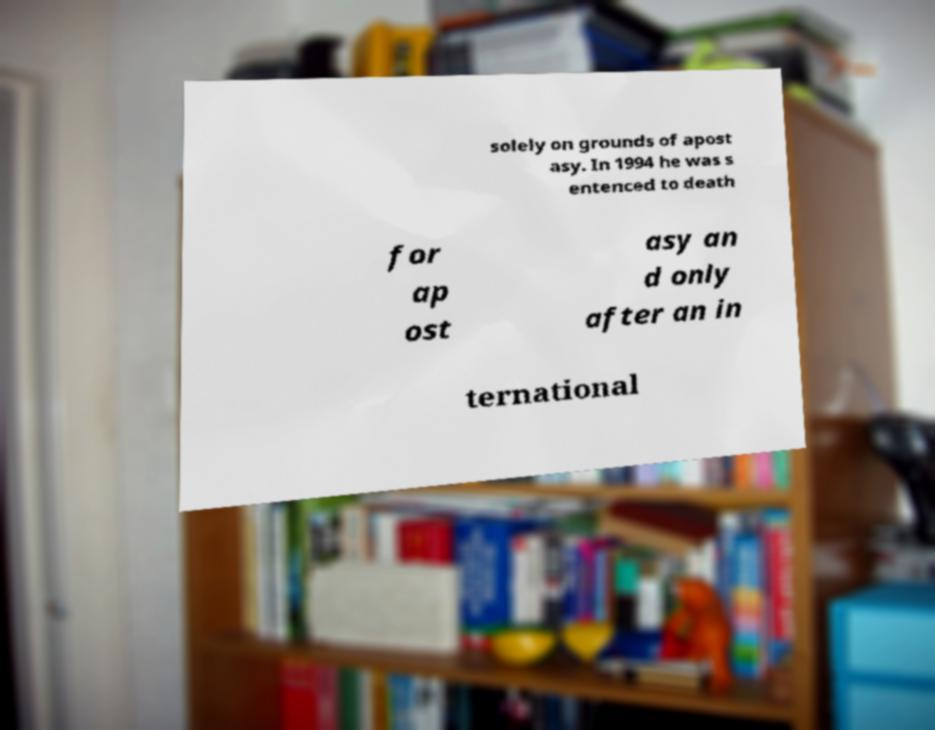For documentation purposes, I need the text within this image transcribed. Could you provide that? solely on grounds of apost asy. In 1994 he was s entenced to death for ap ost asy an d only after an in ternational 